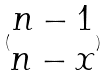Convert formula to latex. <formula><loc_0><loc_0><loc_500><loc_500>( \begin{matrix} n - 1 \\ n - x \end{matrix} )</formula> 